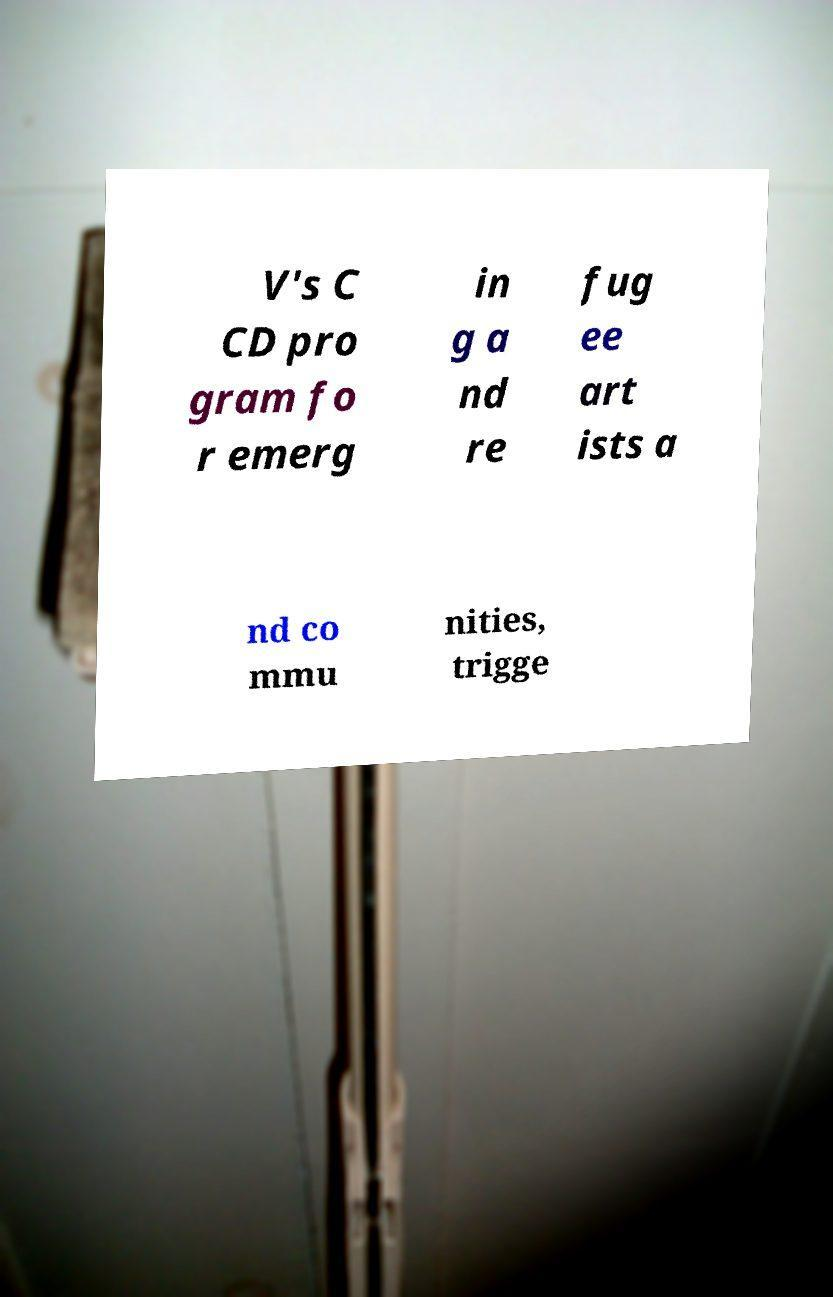Please read and relay the text visible in this image. What does it say? V's C CD pro gram fo r emerg in g a nd re fug ee art ists a nd co mmu nities, trigge 